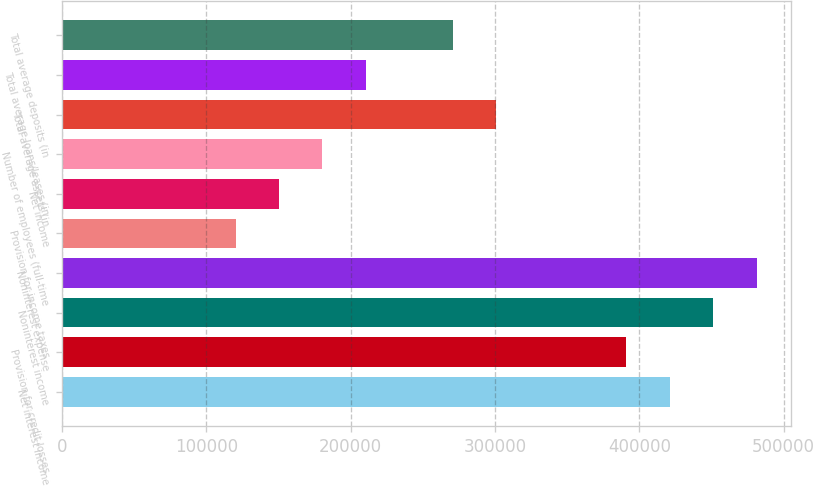Convert chart to OTSL. <chart><loc_0><loc_0><loc_500><loc_500><bar_chart><fcel>Net interest income<fcel>Provision for credit losses<fcel>Noninterest income<fcel>Noninterest expense<fcel>Provision for income taxes<fcel>Net income<fcel>Number of employees (full-time<fcel>Total average assets (in<fcel>Total average loans/leases (in<fcel>Total average deposits (in<nl><fcel>421118<fcel>391039<fcel>451198<fcel>481278<fcel>120320<fcel>150400<fcel>180480<fcel>300799<fcel>210559<fcel>270719<nl></chart> 